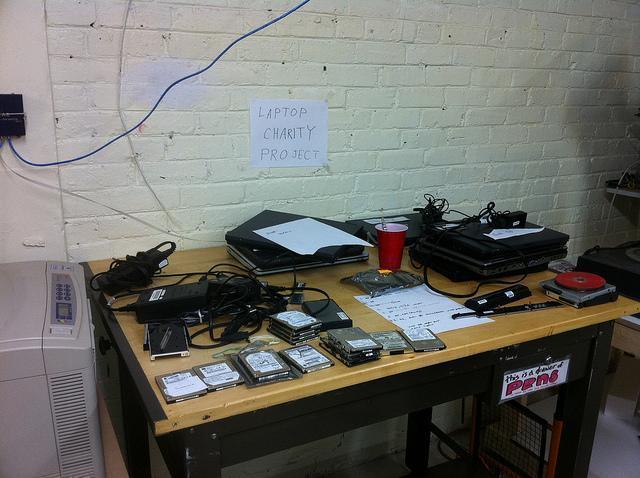What is likely the most valuable object shown?
Select the accurate answer and provide explanation: 'Answer: answer
Rationale: rationale.'
Options: Power bars, photocopier, cds, hard drives. Answer: photocopier.
Rationale: The items are clearly visible in the image. based on their relative costs, answer a is visible and the most valuable. 